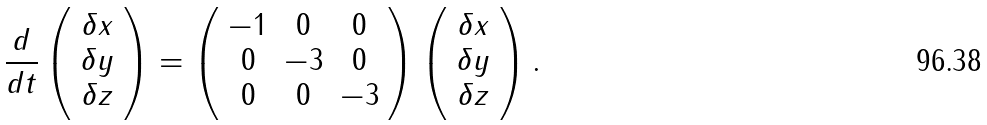Convert formula to latex. <formula><loc_0><loc_0><loc_500><loc_500>\frac { d } { d t } \left ( \begin{array} { c } \delta x \\ \delta y \\ \delta z \end{array} \right ) = \left ( \begin{array} { c c c } - 1 & 0 & 0 \\ 0 & - 3 & 0 \\ 0 & 0 & - 3 \end{array} \right ) \left ( \begin{array} { c } \delta x \\ \delta y \\ \delta z \\ \end{array} \right ) .</formula> 